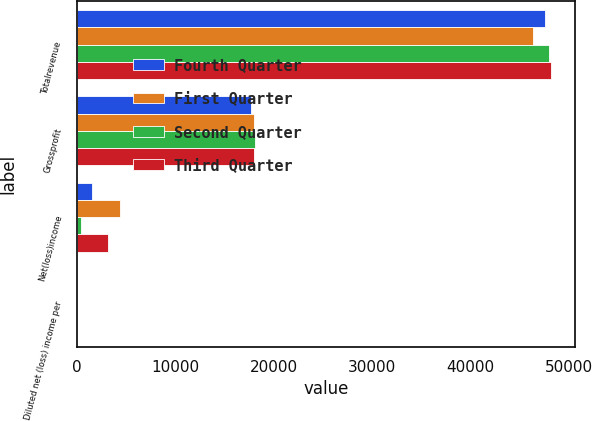<chart> <loc_0><loc_0><loc_500><loc_500><stacked_bar_chart><ecel><fcel>Totalrevenue<fcel>Grossprofit<fcel>Net(loss)income<fcel>Diluted net (loss) income per<nl><fcel>Fourth Quarter<fcel>47585<fcel>17669<fcel>1573<fcel>0.1<nl><fcel>First Quarter<fcel>46401<fcel>18028<fcel>4426<fcel>0.22<nl><fcel>Second Quarter<fcel>48008<fcel>18148<fcel>492<fcel>0.02<nl><fcel>Third Quarter<fcel>48198<fcel>17971<fcel>3166<fcel>0.15<nl></chart> 